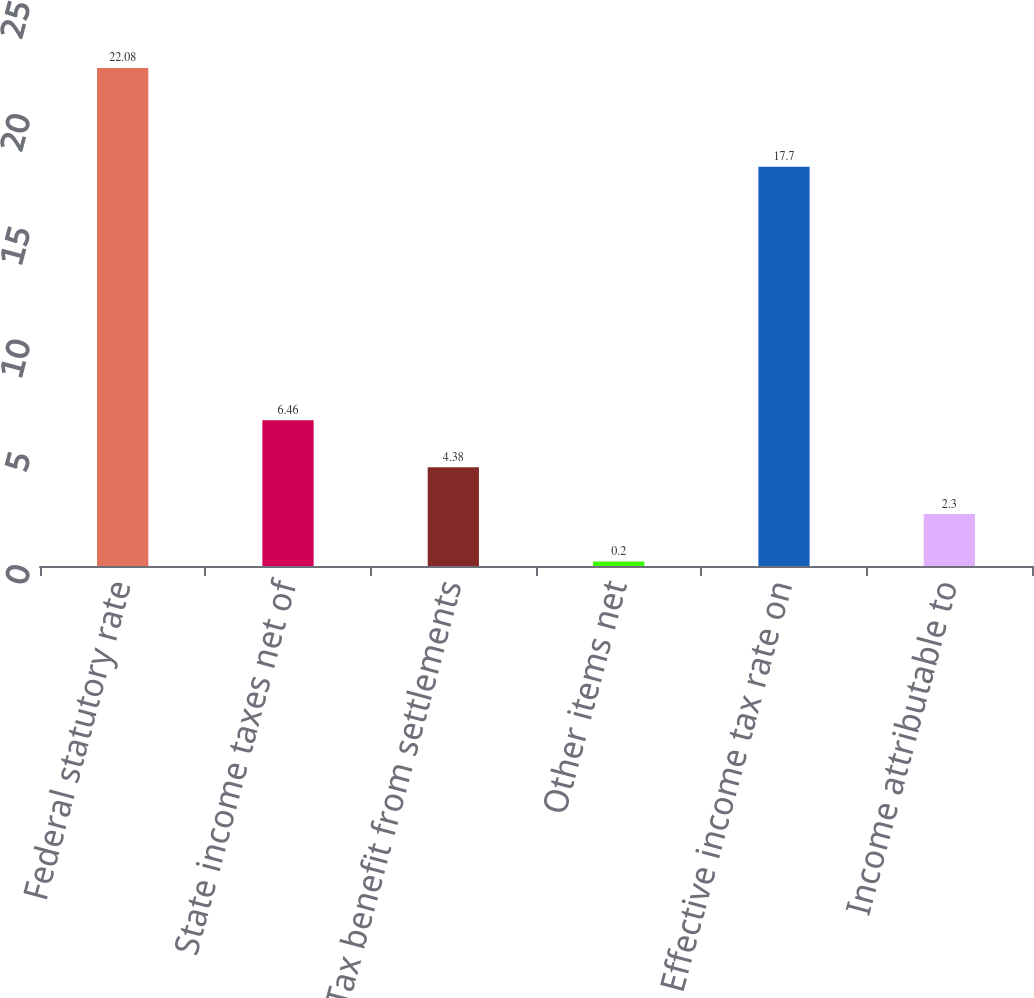<chart> <loc_0><loc_0><loc_500><loc_500><bar_chart><fcel>Federal statutory rate<fcel>State income taxes net of<fcel>Tax benefit from settlements<fcel>Other items net<fcel>Effective income tax rate on<fcel>Income attributable to<nl><fcel>22.08<fcel>6.46<fcel>4.38<fcel>0.2<fcel>17.7<fcel>2.3<nl></chart> 